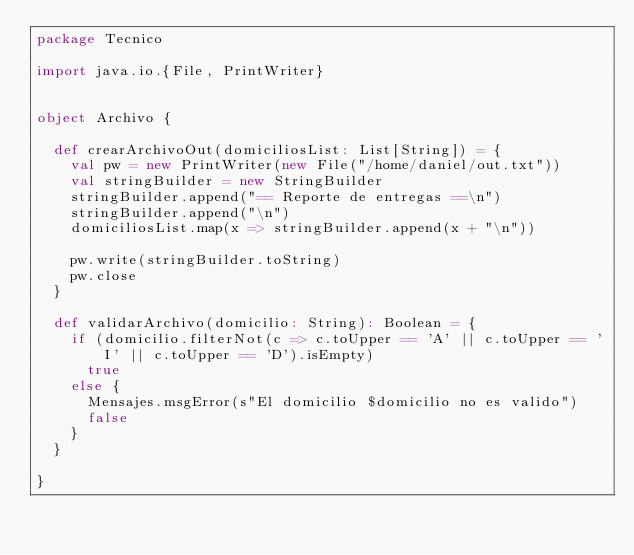<code> <loc_0><loc_0><loc_500><loc_500><_Scala_>package Tecnico

import java.io.{File, PrintWriter}


object Archivo {

  def crearArchivoOut(domiciliosList: List[String]) = {
    val pw = new PrintWriter(new File("/home/daniel/out.txt"))
    val stringBuilder = new StringBuilder
    stringBuilder.append("== Reporte de entregas ==\n")
    stringBuilder.append("\n")
    domiciliosList.map(x => stringBuilder.append(x + "\n"))

    pw.write(stringBuilder.toString)
    pw.close
  }

  def validarArchivo(domicilio: String): Boolean = {
    if (domicilio.filterNot(c => c.toUpper == 'A' || c.toUpper == 'I' || c.toUpper == 'D').isEmpty)
      true
    else {
      Mensajes.msgError(s"El domicilio $domicilio no es valido")
      false
    }
  }

}
</code> 